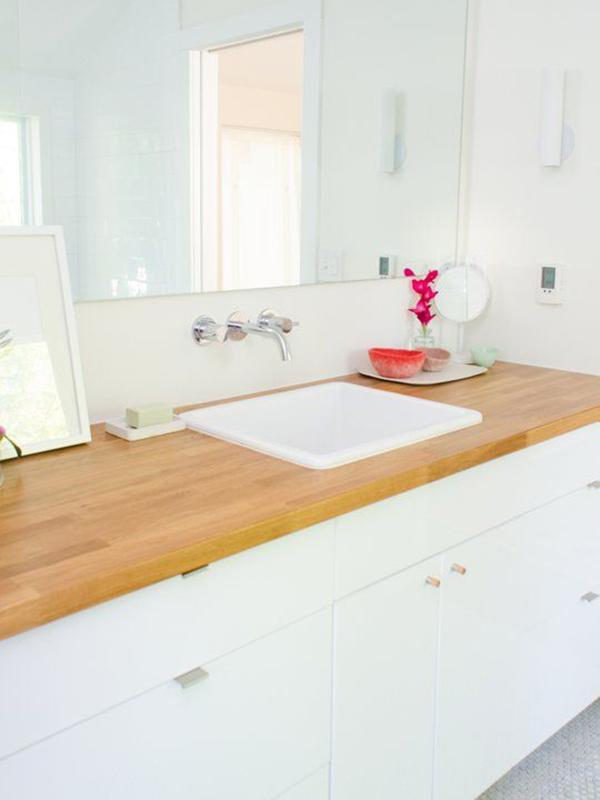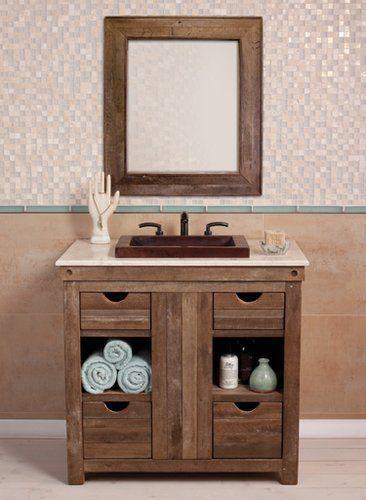The first image is the image on the left, the second image is the image on the right. Analyze the images presented: Is the assertion "All sinks shown sit on top of a vanity, at least some vanities have wood grain, and white towels are underneath at least one vanity." valid? Answer yes or no. No. The first image is the image on the left, the second image is the image on the right. For the images shown, is this caption "A mirror sits behind the sink in each of the images." true? Answer yes or no. Yes. 